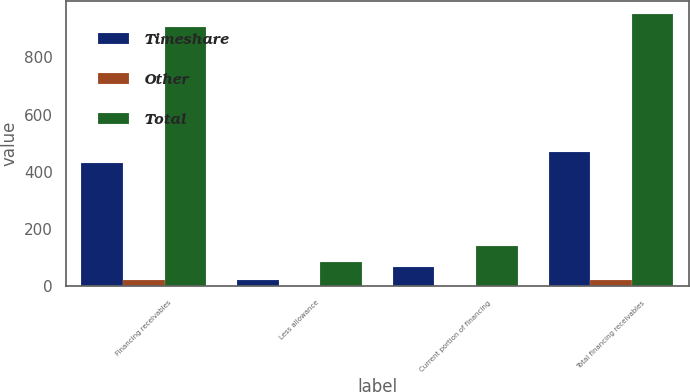<chart> <loc_0><loc_0><loc_500><loc_500><stacked_bar_chart><ecel><fcel>Financing receivables<fcel>Less allowance<fcel>Current portion of financing<fcel>Total financing receivables<nl><fcel>Timeshare<fcel>430<fcel>24<fcel>66<fcel>468<nl><fcel>Other<fcel>22<fcel>2<fcel>2<fcel>22<nl><fcel>Total<fcel>906<fcel>84<fcel>142<fcel>950<nl></chart> 